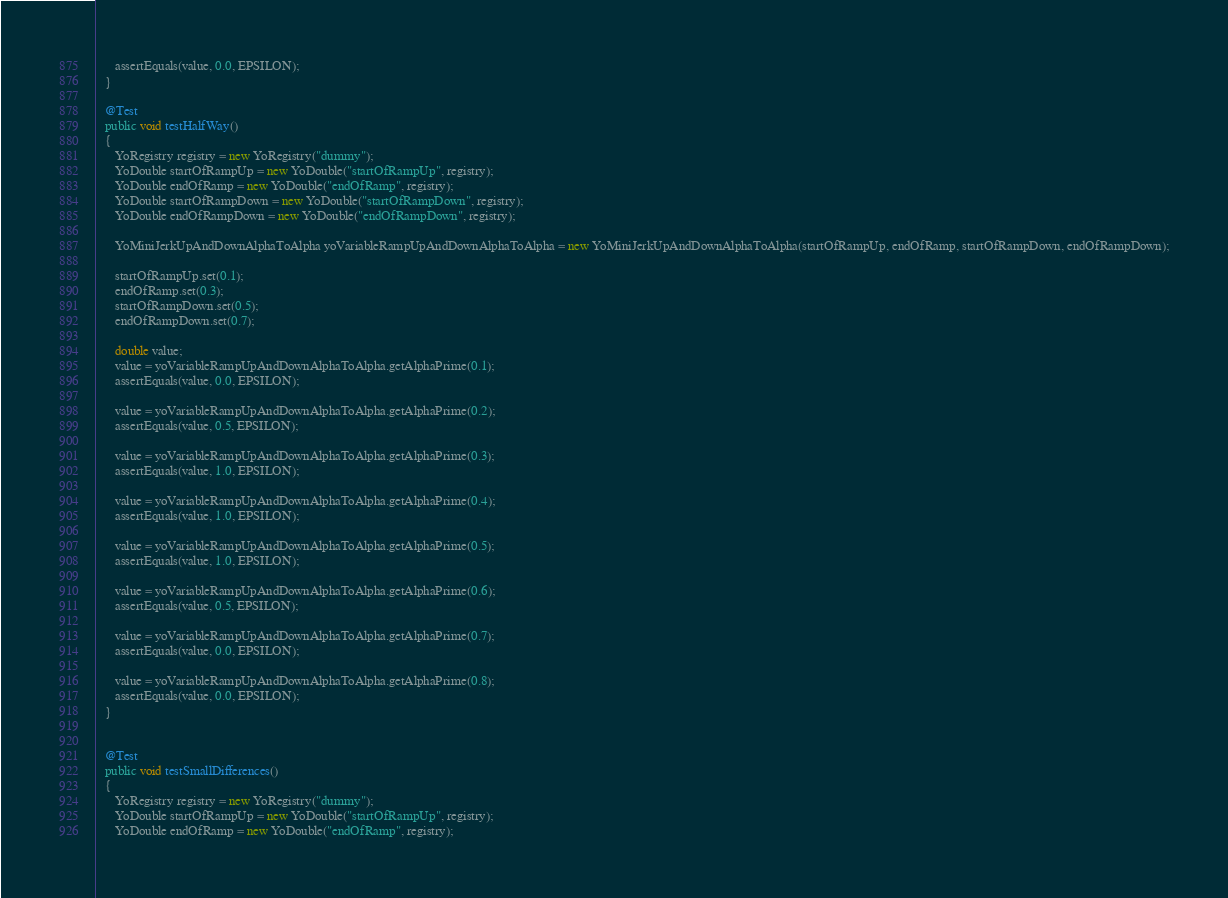<code> <loc_0><loc_0><loc_500><loc_500><_Java_>      assertEquals(value, 0.0, EPSILON);
   }

   @Test
   public void testHalfWay()
   {
      YoRegistry registry = new YoRegistry("dummy");
      YoDouble startOfRampUp = new YoDouble("startOfRampUp", registry);
      YoDouble endOfRamp = new YoDouble("endOfRamp", registry);
      YoDouble startOfRampDown = new YoDouble("startOfRampDown", registry);
      YoDouble endOfRampDown = new YoDouble("endOfRampDown", registry);

      YoMiniJerkUpAndDownAlphaToAlpha yoVariableRampUpAndDownAlphaToAlpha = new YoMiniJerkUpAndDownAlphaToAlpha(startOfRampUp, endOfRamp, startOfRampDown, endOfRampDown);

      startOfRampUp.set(0.1);
      endOfRamp.set(0.3);
      startOfRampDown.set(0.5);
      endOfRampDown.set(0.7);

      double value;
      value = yoVariableRampUpAndDownAlphaToAlpha.getAlphaPrime(0.1);
      assertEquals(value, 0.0, EPSILON);

      value = yoVariableRampUpAndDownAlphaToAlpha.getAlphaPrime(0.2);
      assertEquals(value, 0.5, EPSILON);

      value = yoVariableRampUpAndDownAlphaToAlpha.getAlphaPrime(0.3);
      assertEquals(value, 1.0, EPSILON);

      value = yoVariableRampUpAndDownAlphaToAlpha.getAlphaPrime(0.4);
      assertEquals(value, 1.0, EPSILON);

      value = yoVariableRampUpAndDownAlphaToAlpha.getAlphaPrime(0.5);
      assertEquals(value, 1.0, EPSILON);

      value = yoVariableRampUpAndDownAlphaToAlpha.getAlphaPrime(0.6);
      assertEquals(value, 0.5, EPSILON);

      value = yoVariableRampUpAndDownAlphaToAlpha.getAlphaPrime(0.7);
      assertEquals(value, 0.0, EPSILON);

      value = yoVariableRampUpAndDownAlphaToAlpha.getAlphaPrime(0.8);
      assertEquals(value, 0.0, EPSILON);
   }


   @Test
   public void testSmallDifferences()
   {
      YoRegistry registry = new YoRegistry("dummy");
      YoDouble startOfRampUp = new YoDouble("startOfRampUp", registry);
      YoDouble endOfRamp = new YoDouble("endOfRamp", registry);</code> 